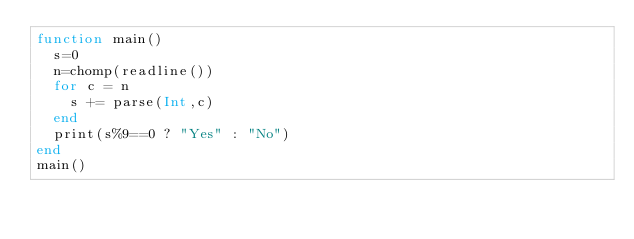Convert code to text. <code><loc_0><loc_0><loc_500><loc_500><_Julia_>function main()
  s=0
  n=chomp(readline())
  for c = n
    s += parse(Int,c)
  end
  print(s%9==0 ? "Yes" : "No")
end
main()</code> 